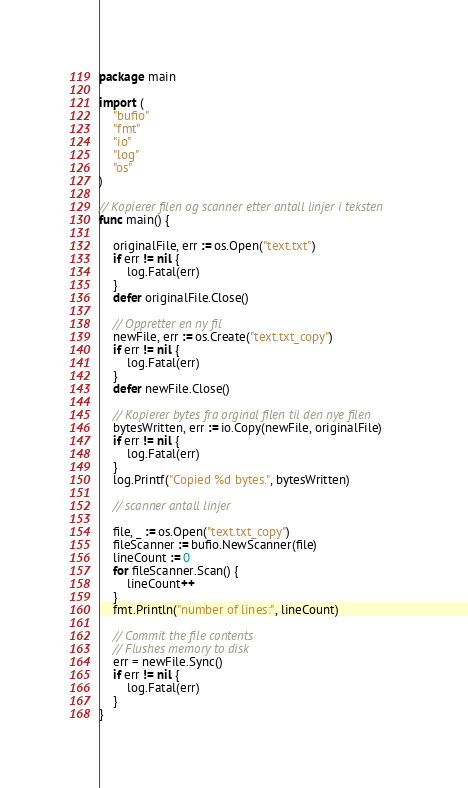Convert code to text. <code><loc_0><loc_0><loc_500><loc_500><_Go_>package main

import (
	"bufio"
	"fmt"
	"io"
	"log"
	"os"
)

// Kopierer filen og scanner etter antall linjer i teksten
func main() {

	originalFile, err := os.Open("text.txt")
	if err != nil {
		log.Fatal(err)
	}
	defer originalFile.Close()

	// Oppretter en ny fil
	newFile, err := os.Create("text.txt_copy")
	if err != nil {
		log.Fatal(err)
	}
	defer newFile.Close()

	// Kopierer bytes fra orginal filen til den nye filen
	bytesWritten, err := io.Copy(newFile, originalFile)
	if err != nil {
		log.Fatal(err)
	}
	log.Printf("Copied %d bytes.", bytesWritten)

	// scanner antall linjer

	file, _ := os.Open("text.txt_copy")
	fileScanner := bufio.NewScanner(file)
	lineCount := 0
	for fileScanner.Scan() {
		lineCount++
	}
	fmt.Println("number of lines:", lineCount)

	// Commit the file contents
	// Flushes memory to disk
	err = newFile.Sync()
	if err != nil {
		log.Fatal(err)
	}
}</code> 